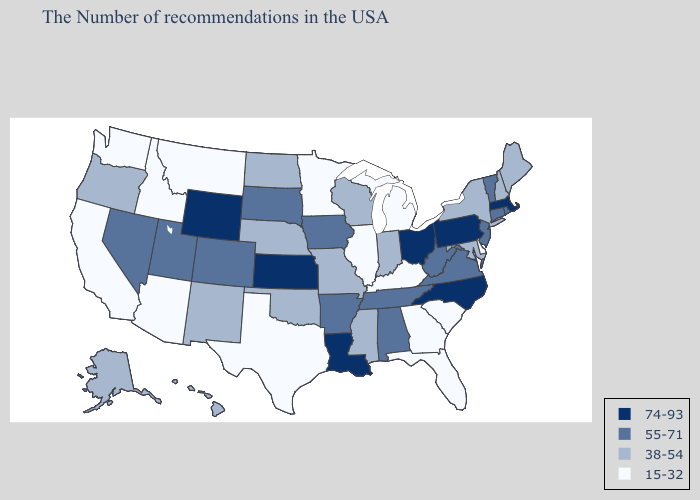What is the value of Iowa?
Concise answer only. 55-71. What is the lowest value in states that border Virginia?
Concise answer only. 15-32. Name the states that have a value in the range 38-54?
Quick response, please. Maine, New Hampshire, New York, Maryland, Indiana, Wisconsin, Mississippi, Missouri, Nebraska, Oklahoma, North Dakota, New Mexico, Oregon, Alaska, Hawaii. What is the lowest value in states that border Georgia?
Concise answer only. 15-32. What is the value of Michigan?
Write a very short answer. 15-32. Does Minnesota have the lowest value in the USA?
Short answer required. Yes. Among the states that border Tennessee , which have the highest value?
Quick response, please. North Carolina. Name the states that have a value in the range 55-71?
Short answer required. Rhode Island, Vermont, Connecticut, New Jersey, Virginia, West Virginia, Alabama, Tennessee, Arkansas, Iowa, South Dakota, Colorado, Utah, Nevada. Among the states that border Arizona , which have the lowest value?
Be succinct. California. What is the lowest value in the USA?
Be succinct. 15-32. Which states have the highest value in the USA?
Quick response, please. Massachusetts, Pennsylvania, North Carolina, Ohio, Louisiana, Kansas, Wyoming. Which states have the lowest value in the USA?
Quick response, please. Delaware, South Carolina, Florida, Georgia, Michigan, Kentucky, Illinois, Minnesota, Texas, Montana, Arizona, Idaho, California, Washington. Which states hav the highest value in the MidWest?
Quick response, please. Ohio, Kansas. Does Wyoming have the highest value in the USA?
Write a very short answer. Yes. 